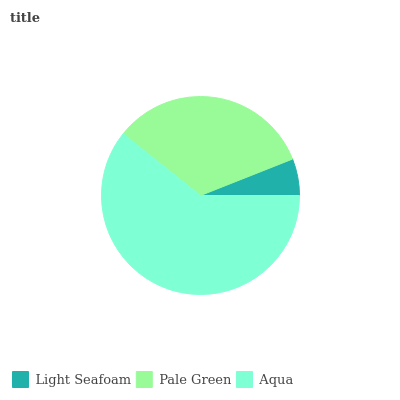Is Light Seafoam the minimum?
Answer yes or no. Yes. Is Aqua the maximum?
Answer yes or no. Yes. Is Pale Green the minimum?
Answer yes or no. No. Is Pale Green the maximum?
Answer yes or no. No. Is Pale Green greater than Light Seafoam?
Answer yes or no. Yes. Is Light Seafoam less than Pale Green?
Answer yes or no. Yes. Is Light Seafoam greater than Pale Green?
Answer yes or no. No. Is Pale Green less than Light Seafoam?
Answer yes or no. No. Is Pale Green the high median?
Answer yes or no. Yes. Is Pale Green the low median?
Answer yes or no. Yes. Is Aqua the high median?
Answer yes or no. No. Is Aqua the low median?
Answer yes or no. No. 